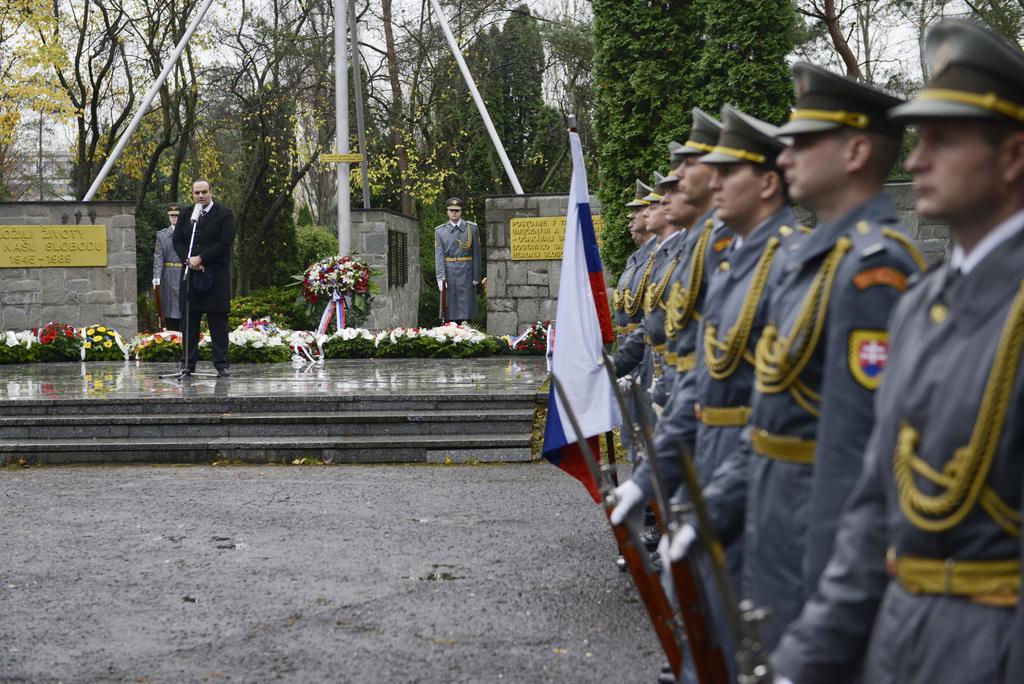How would you summarize this image in a sentence or two? In this image I can see the group of people with uniforms and these people are holding the guns and I can see the flag. In the background I can see the person standing in-front of the mic and I can see two more people. There are many flowers and the yellow color boards to the wall. I can see many trees and the sky in the back. 